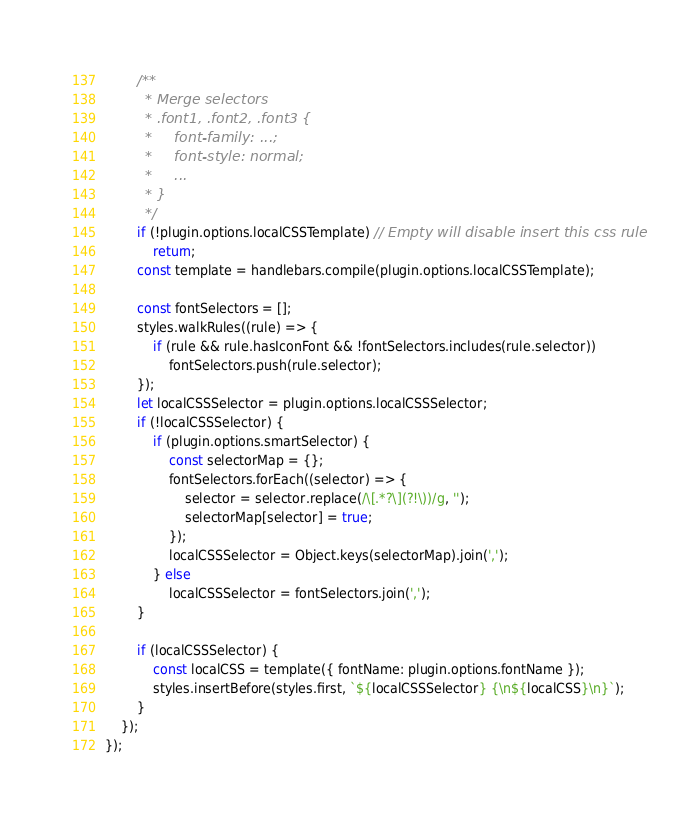<code> <loc_0><loc_0><loc_500><loc_500><_JavaScript_>        /**
         * Merge selectors
         * .font1, .font2, .font3 {
         *     font-family: ...;
         *     font-style: normal;
         *     ...
         * }
         */
        if (!plugin.options.localCSSTemplate) // Empty will disable insert this css rule
            return;
        const template = handlebars.compile(plugin.options.localCSSTemplate);

        const fontSelectors = [];
        styles.walkRules((rule) => {
            if (rule && rule.hasIconFont && !fontSelectors.includes(rule.selector))
                fontSelectors.push(rule.selector);
        });
        let localCSSSelector = plugin.options.localCSSSelector;
        if (!localCSSSelector) {
            if (plugin.options.smartSelector) {
                const selectorMap = {};
                fontSelectors.forEach((selector) => {
                    selector = selector.replace(/\[.*?\](?!\))/g, '');
                    selectorMap[selector] = true;
                });
                localCSSSelector = Object.keys(selectorMap).join(',');
            } else
                localCSSSelector = fontSelectors.join(',');
        }

        if (localCSSSelector) {
            const localCSS = template({ fontName: plugin.options.fontName });
            styles.insertBefore(styles.first, `${localCSSSelector} {\n${localCSS}\n}`);
        }
    });
});
</code> 